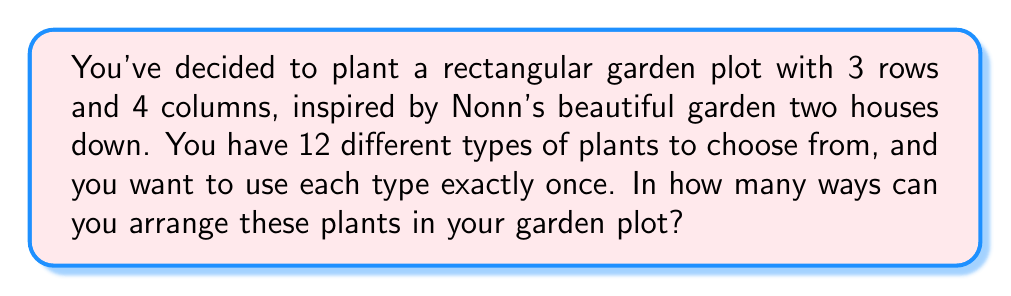What is the answer to this math problem? Let's approach this step-by-step:

1) First, we need to recognize that this is a permutation problem. We are arranging 12 distinct plants in 12 distinct positions (3 rows × 4 columns = 12 total spots).

2) In permutation problems where we are arranging all available items, we use the factorial function.

3) The number of ways to arrange n distinct objects is given by n!

4) In this case, n = 12 (the number of distinct plants)

5) Therefore, the number of ways to arrange the plants is 12!

6) Let's calculate this:

   $$12! = 12 \times 11 \times 10 \times 9 \times 8 \times 7 \times 6 \times 5 \times 4 \times 3 \times 2 \times 1$$

7) This equals:

   $$12! = 479,001,600$$

Thus, there are 479,001,600 different ways to arrange the 12 plants in your garden plot.
Answer: 479,001,600 